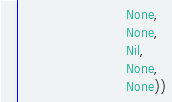Convert code to text. <code><loc_0><loc_0><loc_500><loc_500><_Scala_>                           None,
                           None,
                           Nil,
                           None,
                           None))
</code> 